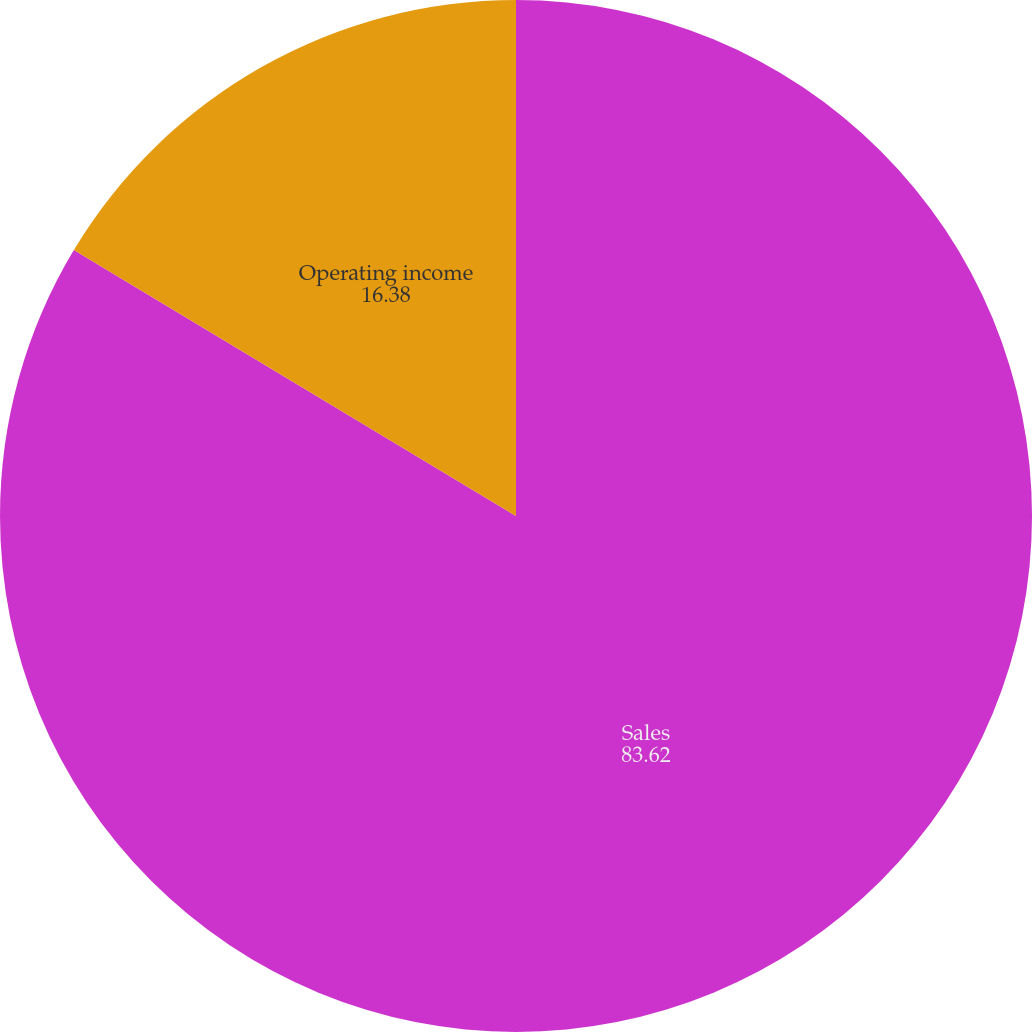Convert chart. <chart><loc_0><loc_0><loc_500><loc_500><pie_chart><fcel>Sales<fcel>Operating income<nl><fcel>83.62%<fcel>16.38%<nl></chart> 